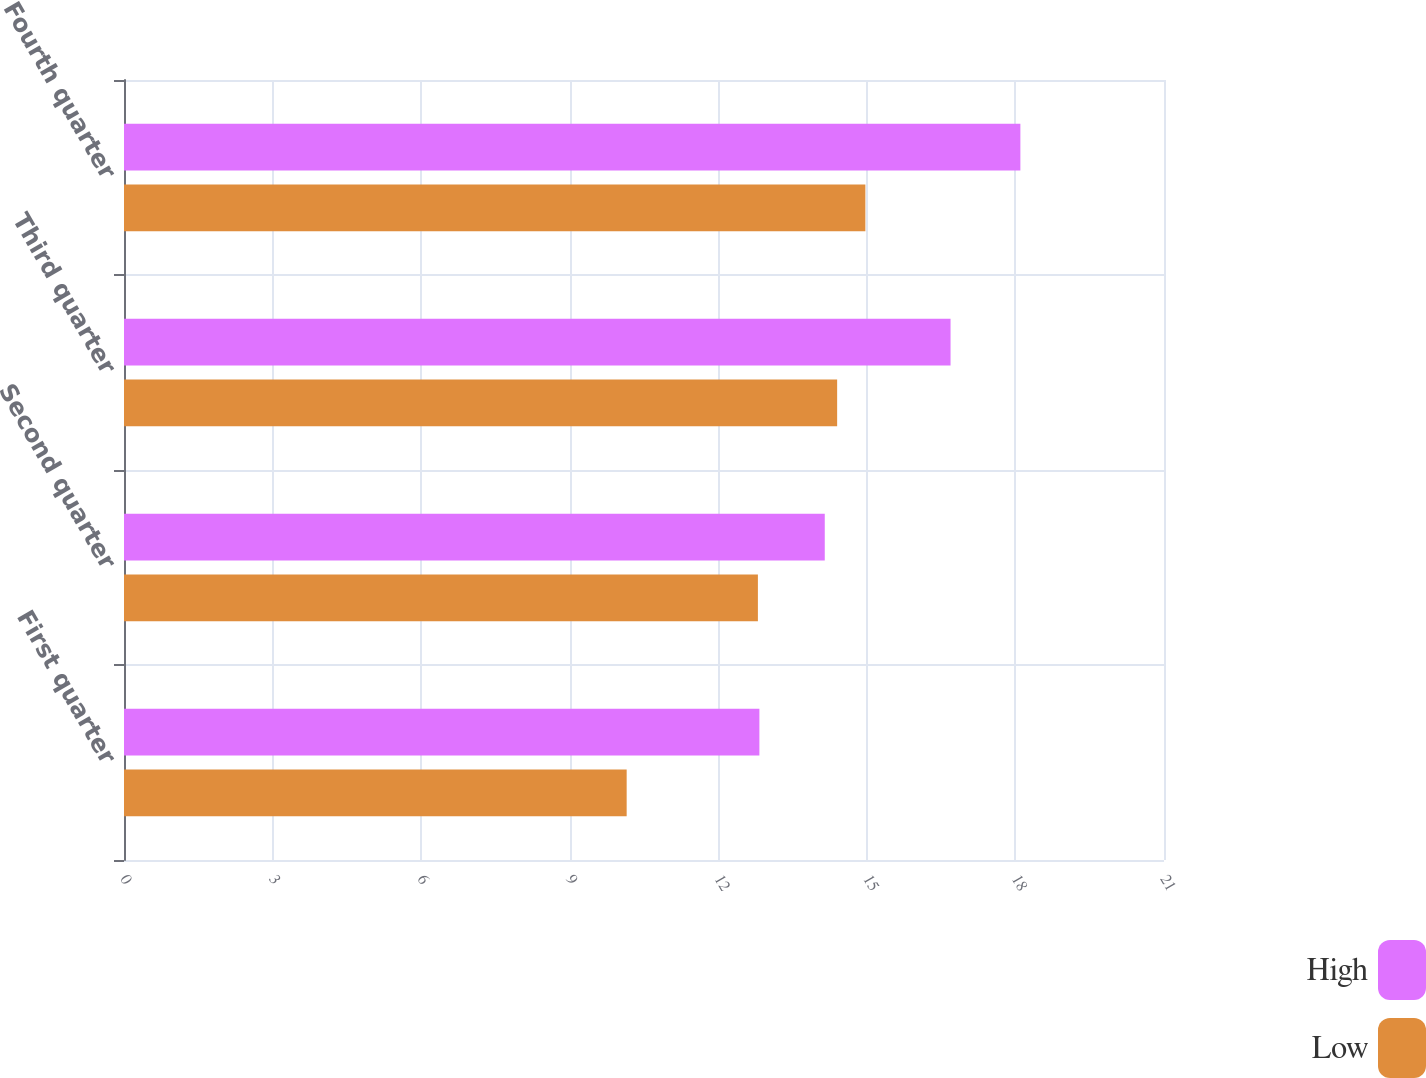Convert chart. <chart><loc_0><loc_0><loc_500><loc_500><stacked_bar_chart><ecel><fcel>First quarter<fcel>Second quarter<fcel>Third quarter<fcel>Fourth quarter<nl><fcel>High<fcel>12.83<fcel>14.15<fcel>16.69<fcel>18.1<nl><fcel>Low<fcel>10.15<fcel>12.8<fcel>14.4<fcel>14.97<nl></chart> 